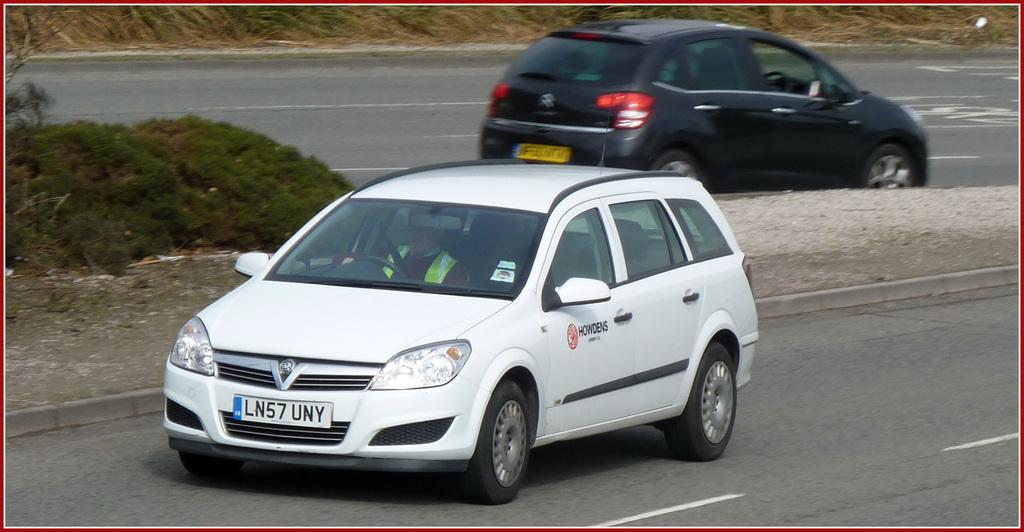<image>
Render a clear and concise summary of the photo. White midsize travelling car with European licence plate number LN57UNY. 